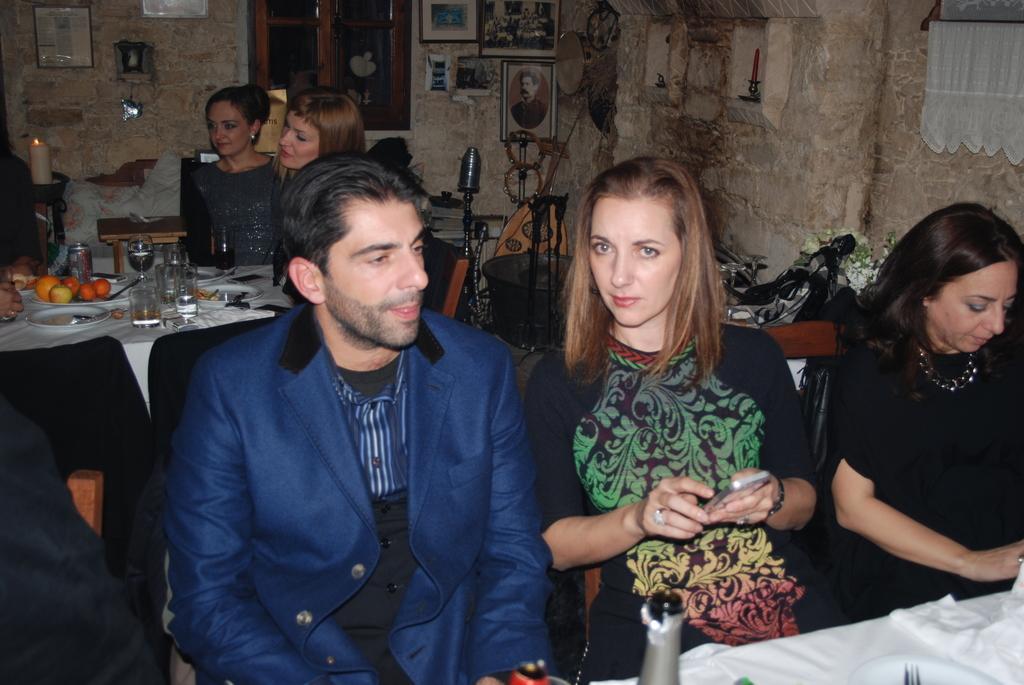Can you describe this image briefly? In this image we can see many people sitting on chairs. One lady is holding a mobile. Also there are tables. On the tables there are glasses, plates, tray with fruits and many other items. In the back there is a wall and windows. On the wall there are photo frames and few other items. In the background there are many other items. On the right side there is a curtain. 